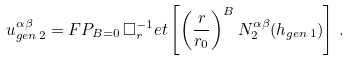<formula> <loc_0><loc_0><loc_500><loc_500>u ^ { \alpha \beta } _ { g e n \, 2 } = F P _ { B = 0 } \, \Box ^ { - 1 } _ { r } e t \left [ \left ( \frac { r } { r _ { 0 } } \right ) ^ { B } N _ { 2 } ^ { \alpha \beta } ( h _ { g e n \, 1 } ) \right ] \, .</formula> 